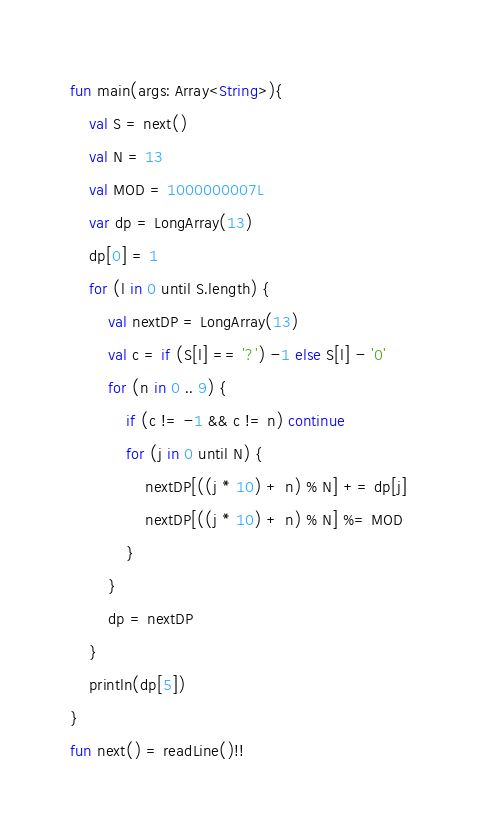<code> <loc_0><loc_0><loc_500><loc_500><_Kotlin_>fun main(args: Array<String>){
    val S = next()
    val N = 13
    val MOD = 1000000007L
    var dp = LongArray(13)
    dp[0] = 1
    for (l in 0 until S.length) {
        val nextDP = LongArray(13)
        val c = if (S[l] == '?') -1 else S[l] - '0'
        for (n in 0 .. 9) {
            if (c != -1 && c != n) continue
            for (j in 0 until N) {
                nextDP[((j * 10) + n) % N] += dp[j]
                nextDP[((j * 10) + n) % N] %= MOD
            }
        }
        dp = nextDP
    }
    println(dp[5])
}
fun next() = readLine()!!</code> 